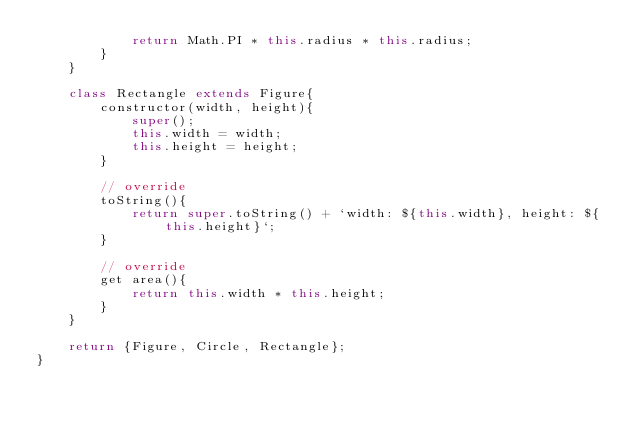Convert code to text. <code><loc_0><loc_0><loc_500><loc_500><_JavaScript_>            return Math.PI * this.radius * this.radius;
        }
    }

    class Rectangle extends Figure{
        constructor(width, height){
            super();
            this.width = width;
            this.height = height;
        }

        // override
        toString(){
            return super.toString() + `width: ${this.width}, height: ${this.height}`;
        }

        // override
        get area(){
            return this.width * this.height;
        }
    }

    return {Figure, Circle, Rectangle};
}</code> 